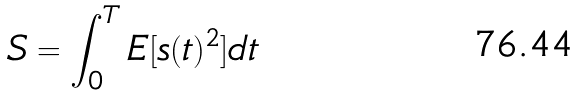<formula> <loc_0><loc_0><loc_500><loc_500>S = \int _ { 0 } ^ { T } E [ s ( t ) ^ { 2 } ] d t</formula> 